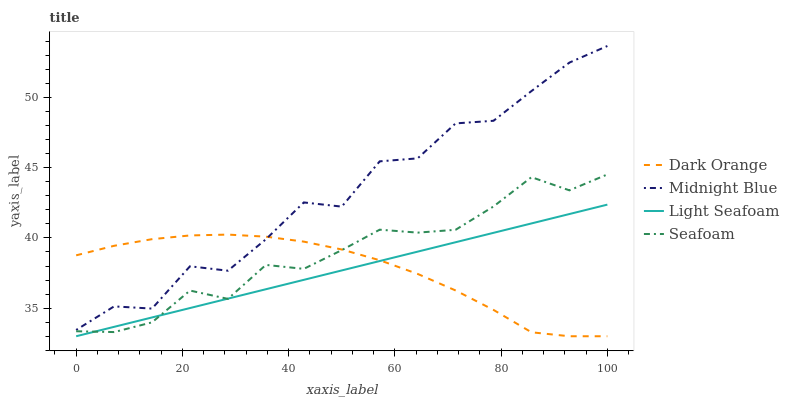Does Light Seafoam have the minimum area under the curve?
Answer yes or no. Yes. Does Midnight Blue have the maximum area under the curve?
Answer yes or no. Yes. Does Midnight Blue have the minimum area under the curve?
Answer yes or no. No. Does Light Seafoam have the maximum area under the curve?
Answer yes or no. No. Is Light Seafoam the smoothest?
Answer yes or no. Yes. Is Midnight Blue the roughest?
Answer yes or no. Yes. Is Midnight Blue the smoothest?
Answer yes or no. No. Is Light Seafoam the roughest?
Answer yes or no. No. Does Dark Orange have the lowest value?
Answer yes or no. Yes. Does Midnight Blue have the lowest value?
Answer yes or no. No. Does Midnight Blue have the highest value?
Answer yes or no. Yes. Does Light Seafoam have the highest value?
Answer yes or no. No. Is Seafoam less than Midnight Blue?
Answer yes or no. Yes. Is Midnight Blue greater than Light Seafoam?
Answer yes or no. Yes. Does Dark Orange intersect Midnight Blue?
Answer yes or no. Yes. Is Dark Orange less than Midnight Blue?
Answer yes or no. No. Is Dark Orange greater than Midnight Blue?
Answer yes or no. No. Does Seafoam intersect Midnight Blue?
Answer yes or no. No. 